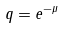<formula> <loc_0><loc_0><loc_500><loc_500>q = e ^ { - \mu }</formula> 